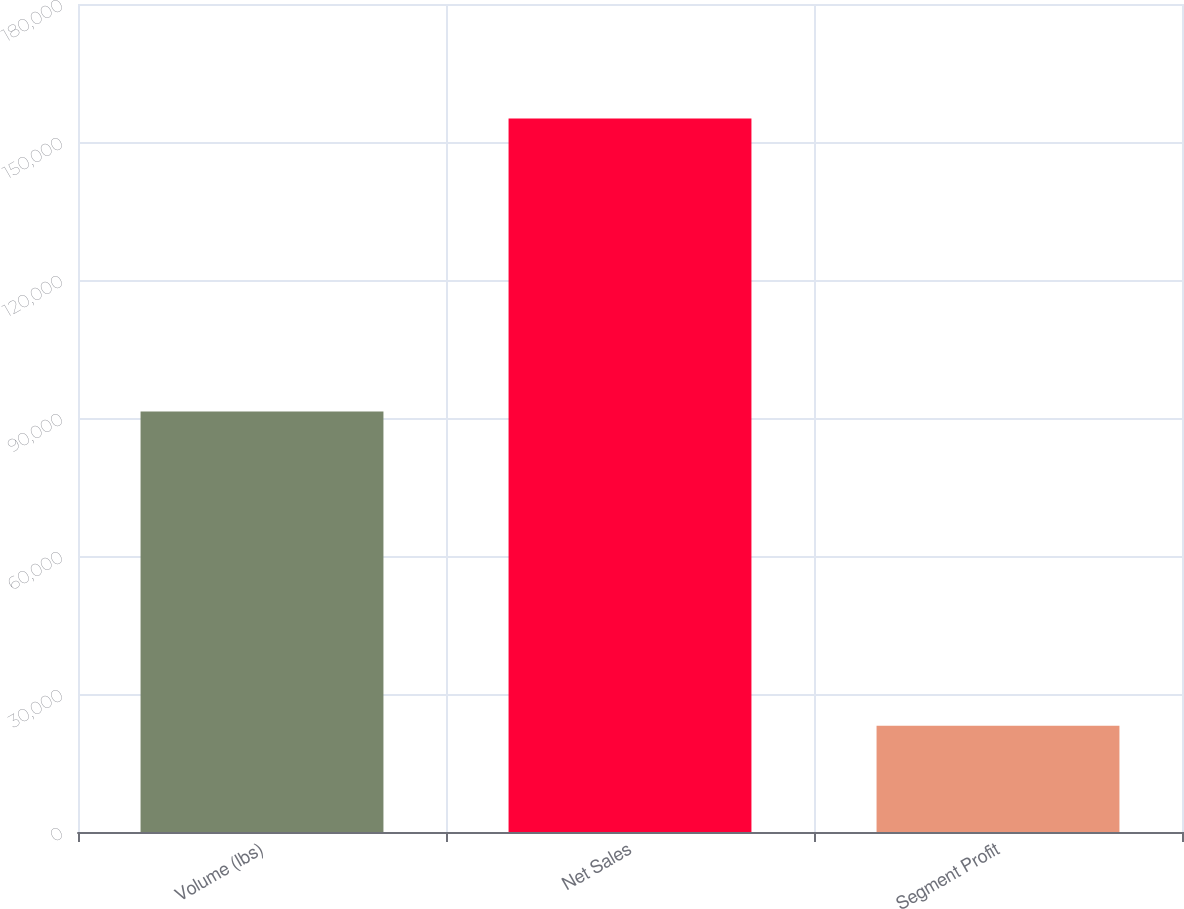Convert chart to OTSL. <chart><loc_0><loc_0><loc_500><loc_500><bar_chart><fcel>Volume (lbs)<fcel>Net Sales<fcel>Segment Profit<nl><fcel>91414<fcel>155130<fcel>23113<nl></chart> 